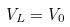<formula> <loc_0><loc_0><loc_500><loc_500>V _ { L } = V _ { 0 }</formula> 